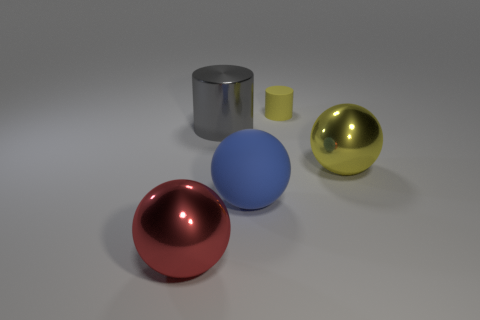Subtract all red balls. Subtract all purple blocks. How many balls are left? 2 Subtract all red balls. How many brown cylinders are left? 0 Add 3 large blues. How many yellows exist? 0 Subtract all big gray objects. Subtract all small yellow matte things. How many objects are left? 3 Add 4 small objects. How many small objects are left? 5 Add 4 tiny yellow cylinders. How many tiny yellow cylinders exist? 5 Add 5 tiny yellow matte things. How many objects exist? 10 Subtract all red balls. How many balls are left? 2 Subtract all large yellow metallic spheres. How many spheres are left? 2 Subtract 0 green cylinders. How many objects are left? 5 